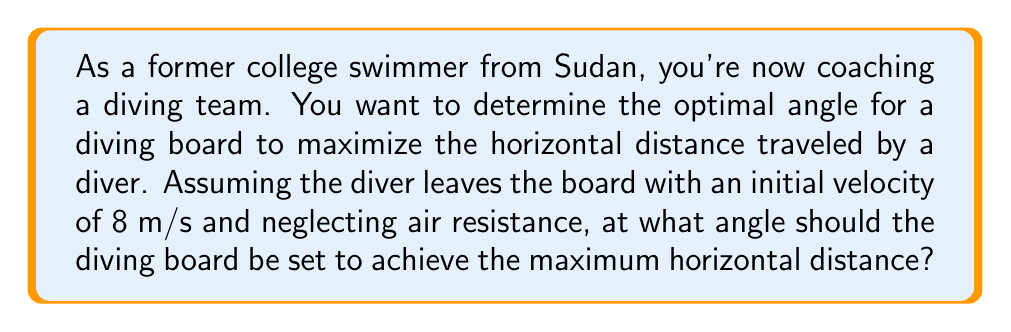Solve this math problem. To solve this problem, we need to use the principles of projectile motion. The horizontal distance traveled by a projectile is given by the equation:

$$R = \frac{v^2 \sin(2\theta)}{g}$$

Where:
$R$ is the horizontal distance
$v$ is the initial velocity
$\theta$ is the launch angle
$g$ is the acceleration due to gravity (9.8 m/s²)

To find the maximum distance, we need to maximize $\sin(2\theta)$. The sine function reaches its maximum value of 1 when its argument is 90°. Therefore:

$$2\theta = 90°$$
$$\theta = 45°$$

We can verify this by calculating the horizontal distance for different angles:

For $\theta = 45°$:
$$R = \frac{8^2 \sin(2 \cdot 45°)}{9.8} = \frac{64 \cdot 1}{9.8} \approx 6.53\text{ m}$$

For $\theta = 30°$ or $60°$:
$$R = \frac{8^2 \sin(2 \cdot 30°)}{9.8} = \frac{64 \cdot 0.866}{9.8} \approx 5.66\text{ m}$$

This confirms that 45° indeed gives the maximum distance.

[asy]
import geometry;

size(200);
draw((-1,0)--(7,0), arrow=Arrow(TeXHead));
draw((0,-1)--(0,4), arrow=Arrow(TeXHead));
draw((0,0)--(5,5), arrow=Arrow(TeXHead));

label("45°", (0.7,0.7), NE);
label("$v_0 = 8\text{ m/s}$", (2.5,2.5), NW);
label("$x$", (7,-0.3));
label("$y$", (0.3,4));

dot((0,0));
[/asy]
Answer: The optimal angle for the diving board to maximize horizontal distance is 45°. 